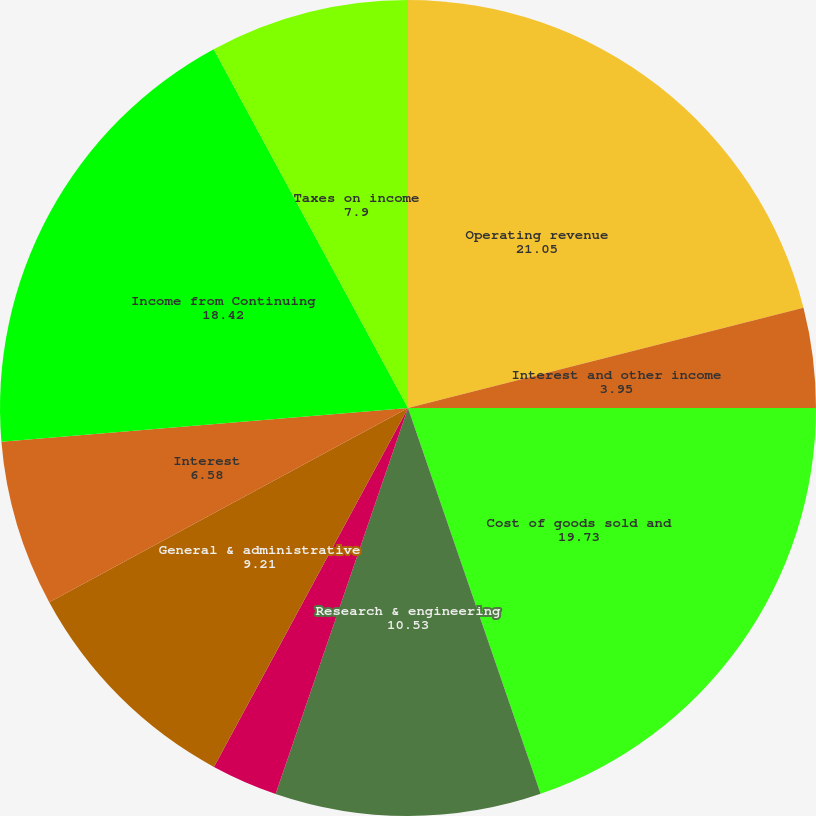<chart> <loc_0><loc_0><loc_500><loc_500><pie_chart><fcel>Year Ended December 31<fcel>Operating revenue<fcel>Interest and other income<fcel>Cost of goods sold and<fcel>Research & engineering<fcel>Marketing<fcel>General & administrative<fcel>Interest<fcel>Income from Continuing<fcel>Taxes on income<nl><fcel>0.0%<fcel>21.05%<fcel>3.95%<fcel>19.73%<fcel>10.53%<fcel>2.63%<fcel>9.21%<fcel>6.58%<fcel>18.42%<fcel>7.9%<nl></chart> 